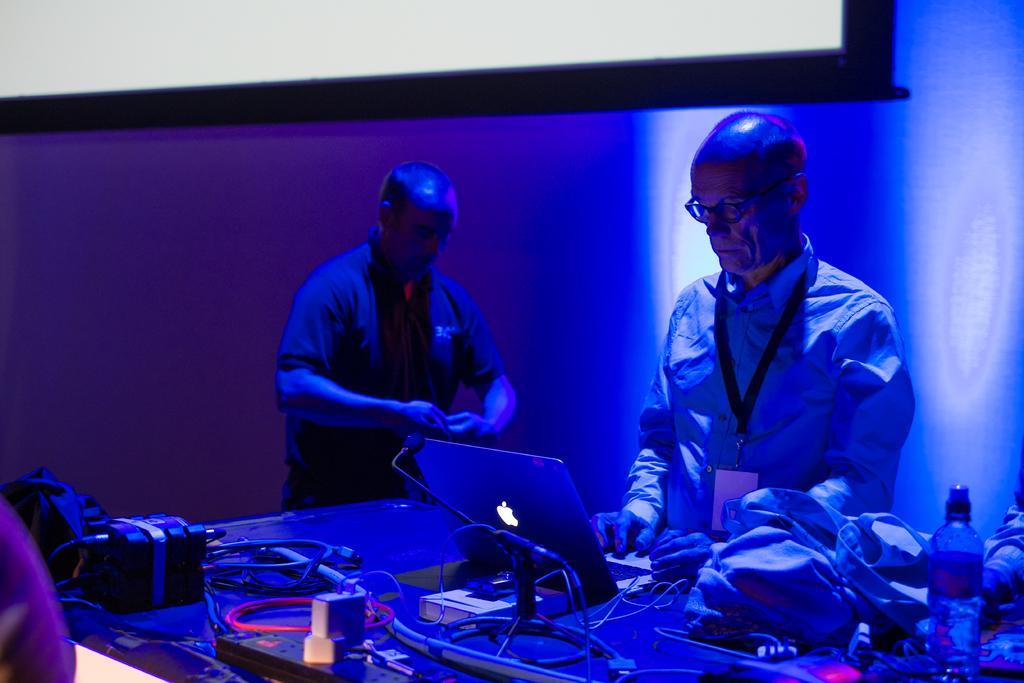Please provide a concise description of this image. In this image there are two people standing beside the table where one of them is operating laptop beside that there is a cloth and water bottle and also there is a box where cables are connected. 